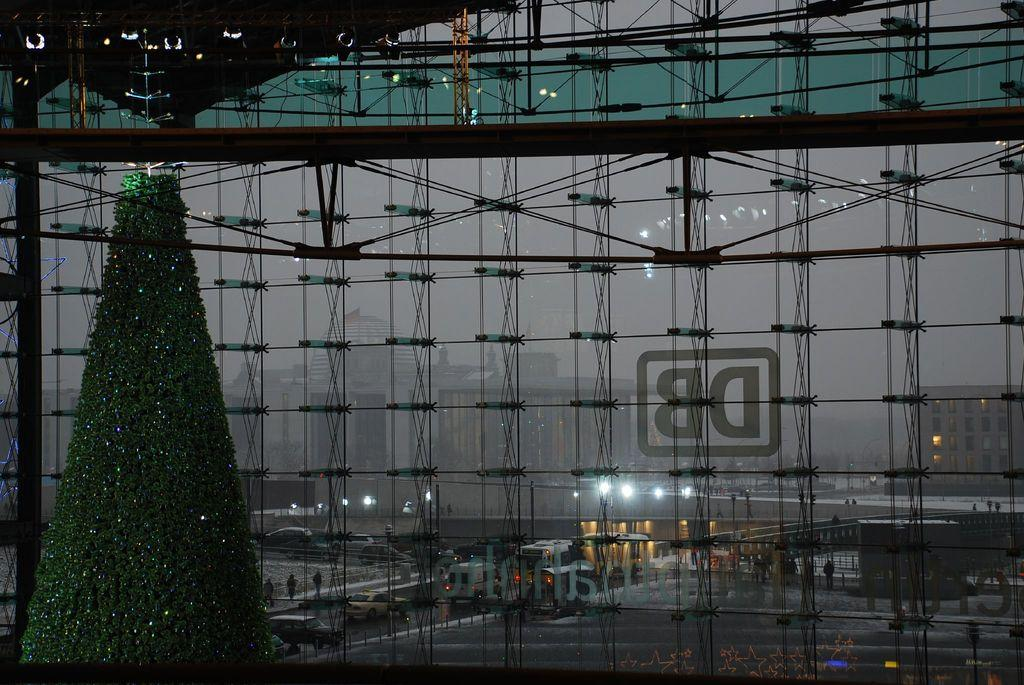What is the main subject of the picture? The main subject of the picture is a decorated tree. What can be seen through the glass wall in the picture? The glass wall provides a view of buildings, a road, and vehicles. What is happening on the road in the picture? There are people walking on the road. What is the condition of the sky in the picture? The sky is clear in the picture. Can you tell me how many airplanes are flying over the camp in the image? There is no camp or airplanes present in the image; it features a decorated tree and a view through a glass wall. What type of bulb is used to light up the decorated tree in the image? The image does not provide information about the type of bulb used to light up the decorated tree. 